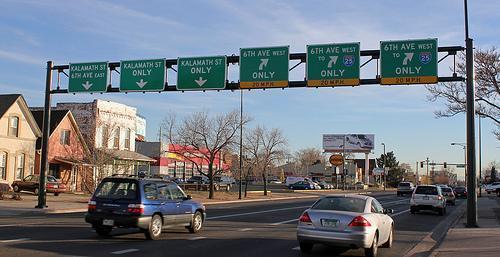How many cars are under the signs?
Give a very brief answer. 2. 